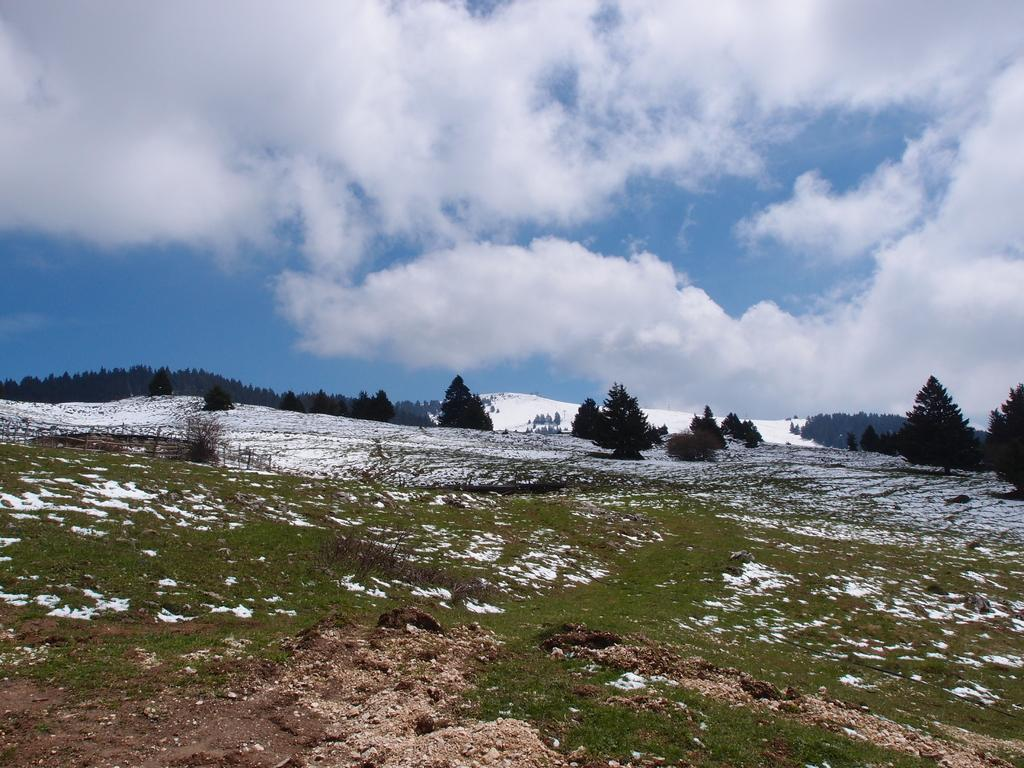What type of surface can be seen in the image? The ground is visible in the image. What is covering the ground? There is grass and snow on the ground. What can be seen in the background of the image? There are trees and the sky visible in the background of the image. Where is the kettle located in the image? There is no kettle present in the image. What type of animal can be seen interacting with the snow in the image? There are no animals visible in the image; it only features grass, snow, trees, and the sky. 